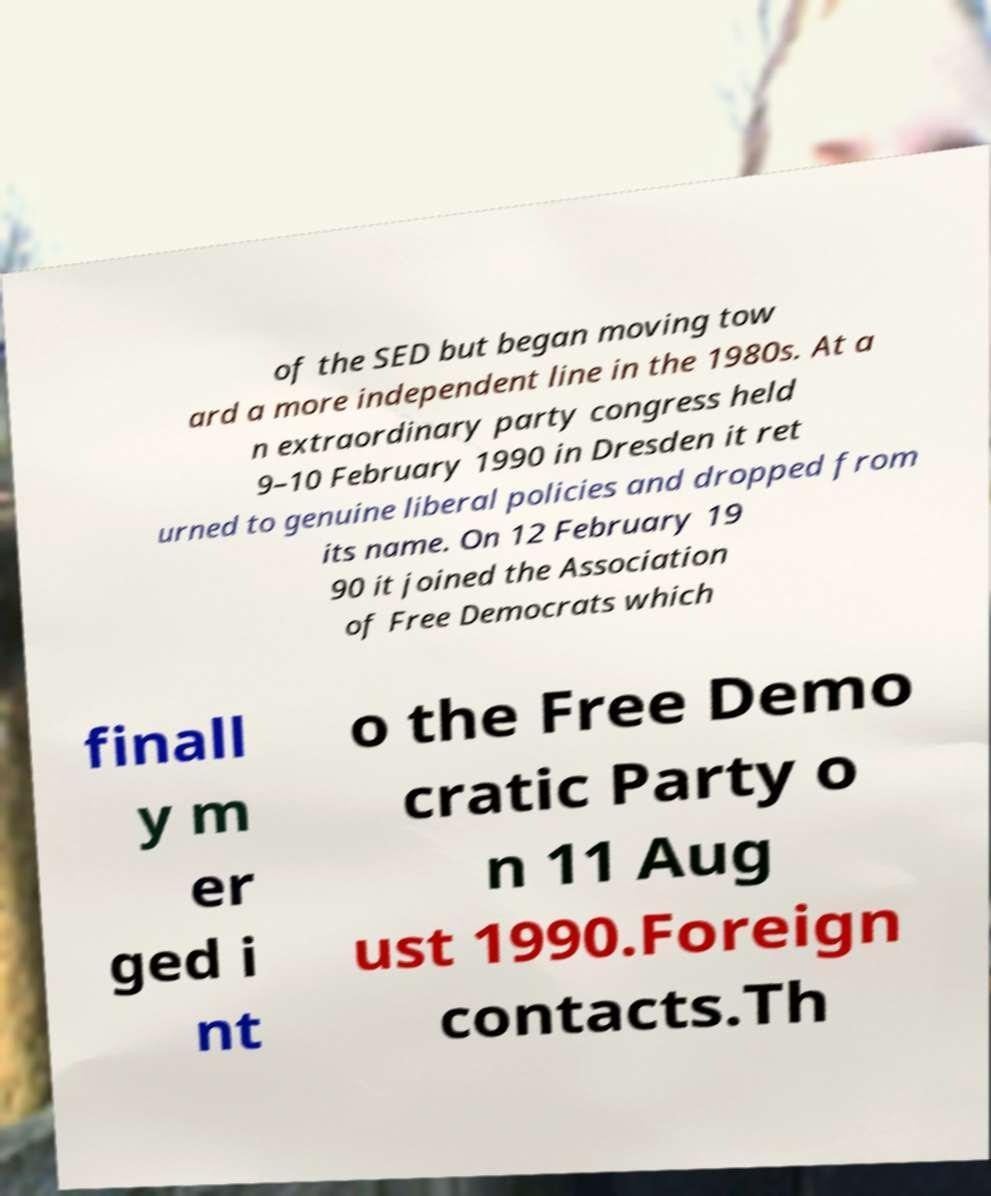Please identify and transcribe the text found in this image. of the SED but began moving tow ard a more independent line in the 1980s. At a n extraordinary party congress held 9–10 February 1990 in Dresden it ret urned to genuine liberal policies and dropped from its name. On 12 February 19 90 it joined the Association of Free Democrats which finall y m er ged i nt o the Free Demo cratic Party o n 11 Aug ust 1990.Foreign contacts.Th 